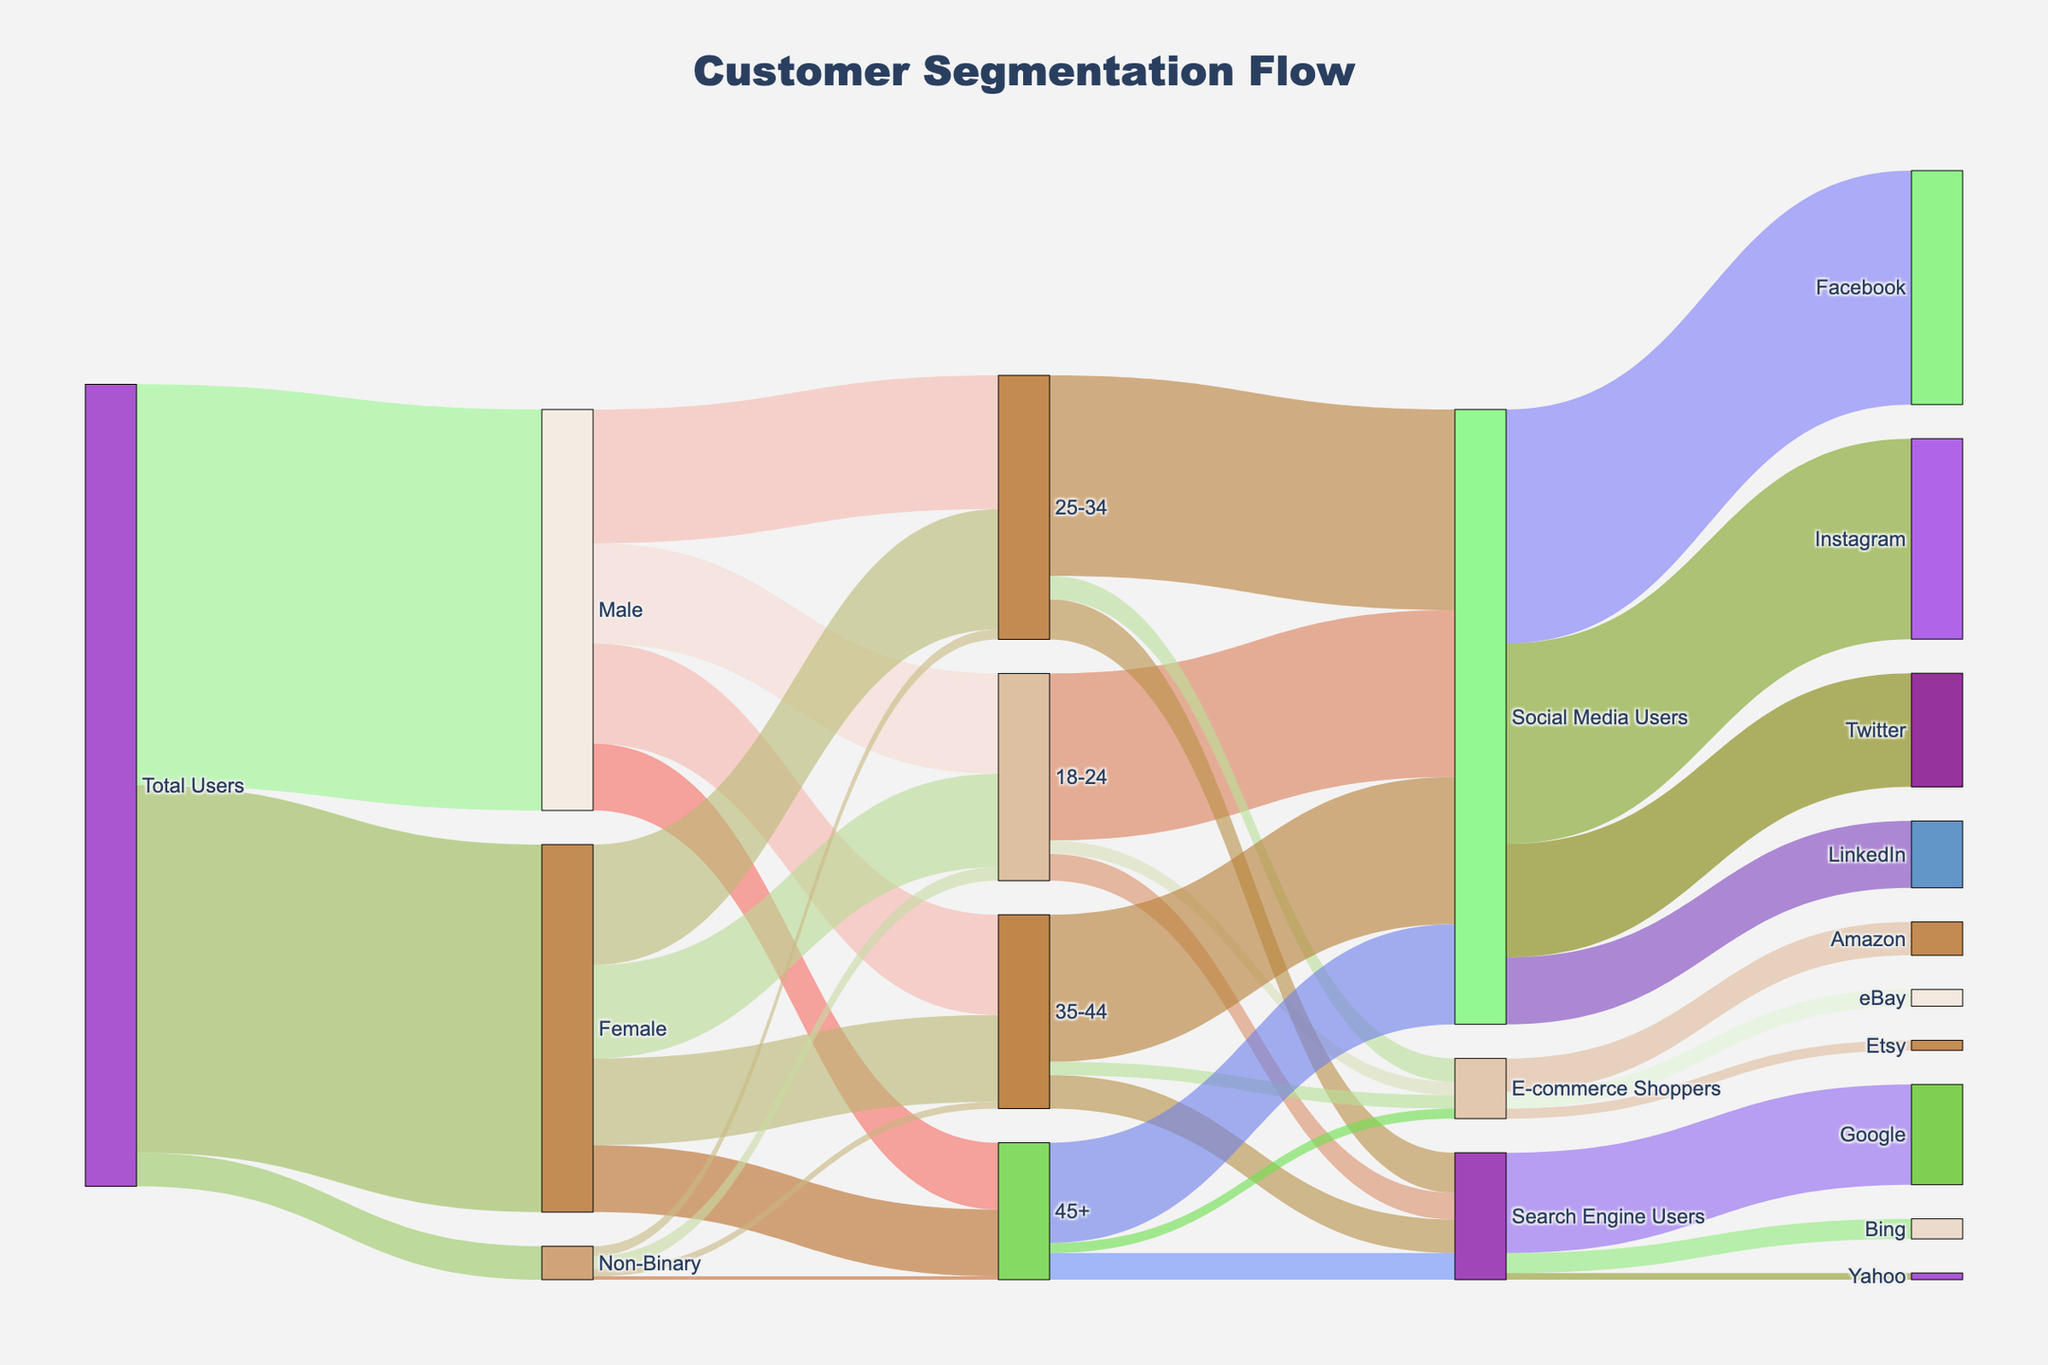What is the total number of Female users? The figure shows that "Total Users" flow into "Female" which has a value of 5500.
Answer: 5500 How many users are aged 25-34? Users aged 25-34 are the sum of those categorized under "Male," "Female," and "Non-Binary" who fall within this age group. 2000 (Male) + 1800 (Female) + 150 (Non-Binary) = 3950 users.
Answer: 3950 Which demographic group has the least value in the 35-44 age category? In the 35-44 age category, the flow values are 1500 (Male), 1300 (Female), and 100 (Non-Binary). Non-Binary has the lowest value.
Answer: Non-Binary Between Social Media Users and E-commerce Shoppers, which has more users in the 18-24 age group? Social Media Users in the 18-24 age group have a value of 2500, whereas E-commerce Shoppers have a value of 200. Therefore, Social Media Users have more users.
Answer: Social Media Users How many total Social Media Users are there? Summing up the values flowing into "Social Media Users": 2500 (18-24) + 3000 (25-34) + 2200 (35-44) + 1500 (45+). Total = 2500 + 3000 + 2200 + 1500 = 9200.
Answer: 9200 Which platform has the highest number of Social Media Users? Among the social media platforms, the values are: Facebook (3500), Instagram (3000), Twitter (1700), LinkedIn (1000). Facebook has the highest number of users.
Answer: Facebook What are the total users who use Search Engines? Summing up the values flowing into "Search Engine Users": 400 (18-24) + 600 (25-34) + 500 (35-44) + 400 (45+). Total = 400 + 600 + 500 + 400 = 1900.
Answer: 1900 How many 45+ age users are engaged in E-commerce shopping? The figure shows 150 users in the "45+" age group designated as "E-commerce Shoppers".
Answer: 150 Which group has more users: Search Engine Users or E-commerce Shoppers? By summing up the number of users in each group across all age categories: Search Engine Users (400 + 600 + 500 + 400 = 1900) and E-commerce Shoppers (200 + 350 + 200 + 150 = 900). Therefore, Search Engine Users have more users.
Answer: Search Engine Users How many Non-Binary users prefer using LinkedIn? This question requires tracing through "Social Media Users" where LinkedIn has 1000 users in total; however, the diagram does not specifically break down LinkedIn users by gender, so this information is not directly available from the diagram.
Answer: Not available 